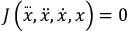Convert formula to latex. <formula><loc_0><loc_0><loc_500><loc_500>J \left ( { \overset { \dots } { x } } , { \ddot { x } } , { \dot { x } } , x \right ) = 0</formula> 